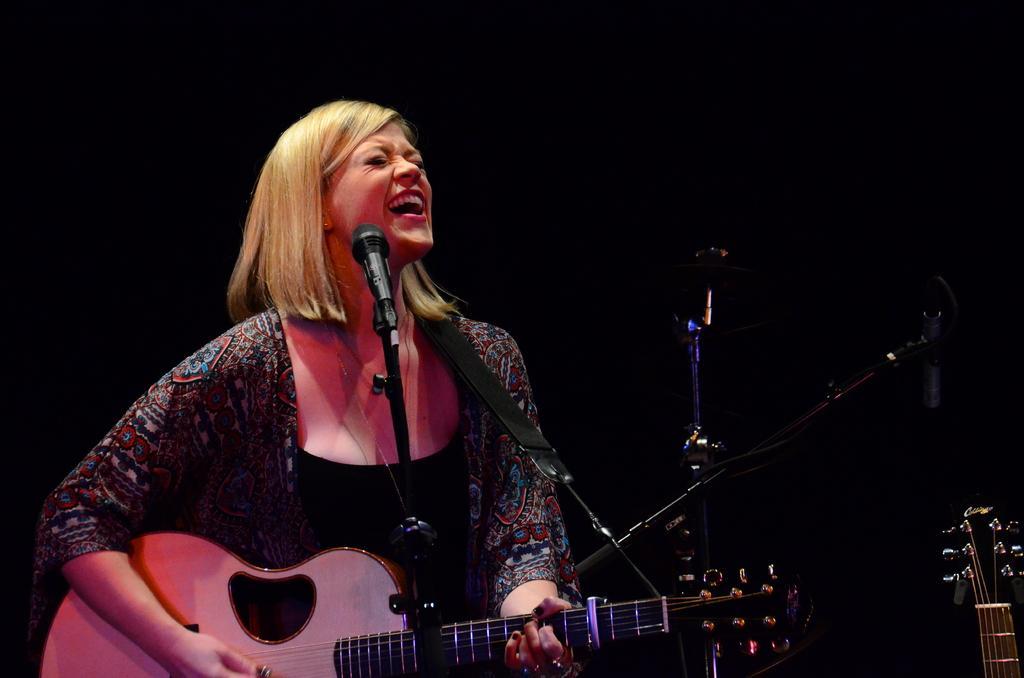Describe this image in one or two sentences. In this image I can see a woman , in front of the woman I can see a mike and a woman holding a guitar ,beside the woman I can see musical instrument and in the background I can see dark view and woman mouth is open. 